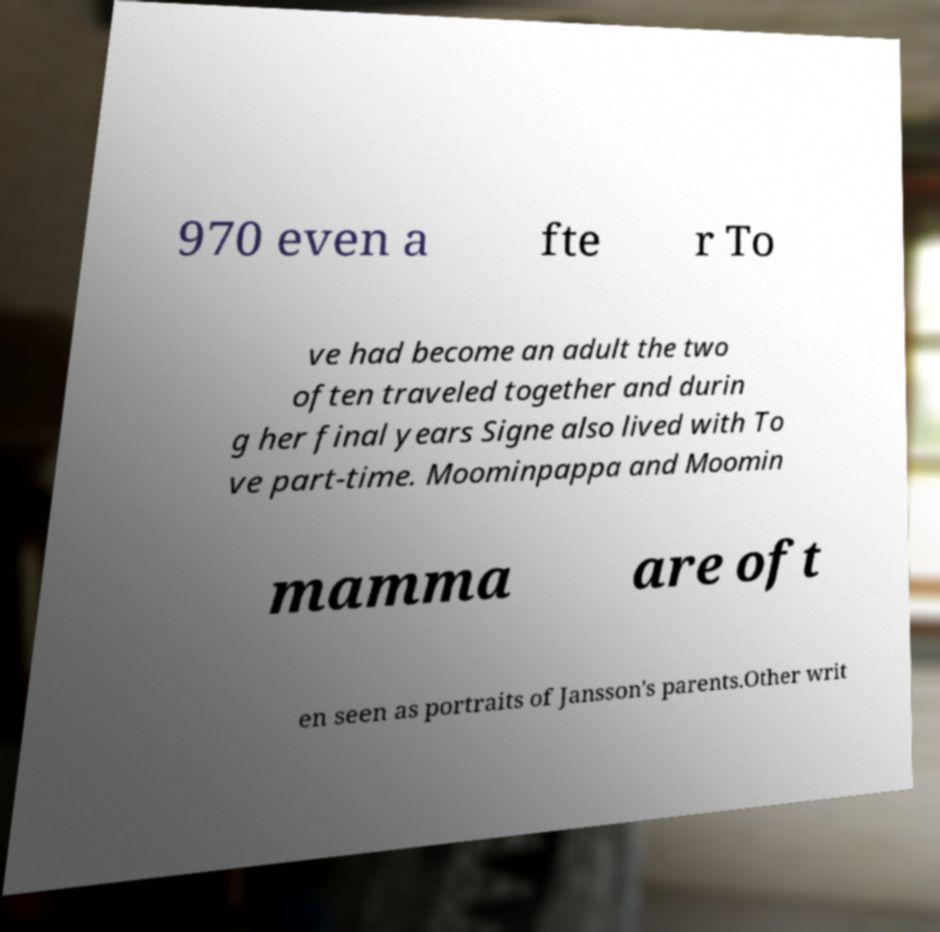Can you accurately transcribe the text from the provided image for me? 970 even a fte r To ve had become an adult the two often traveled together and durin g her final years Signe also lived with To ve part-time. Moominpappa and Moomin mamma are oft en seen as portraits of Jansson's parents.Other writ 